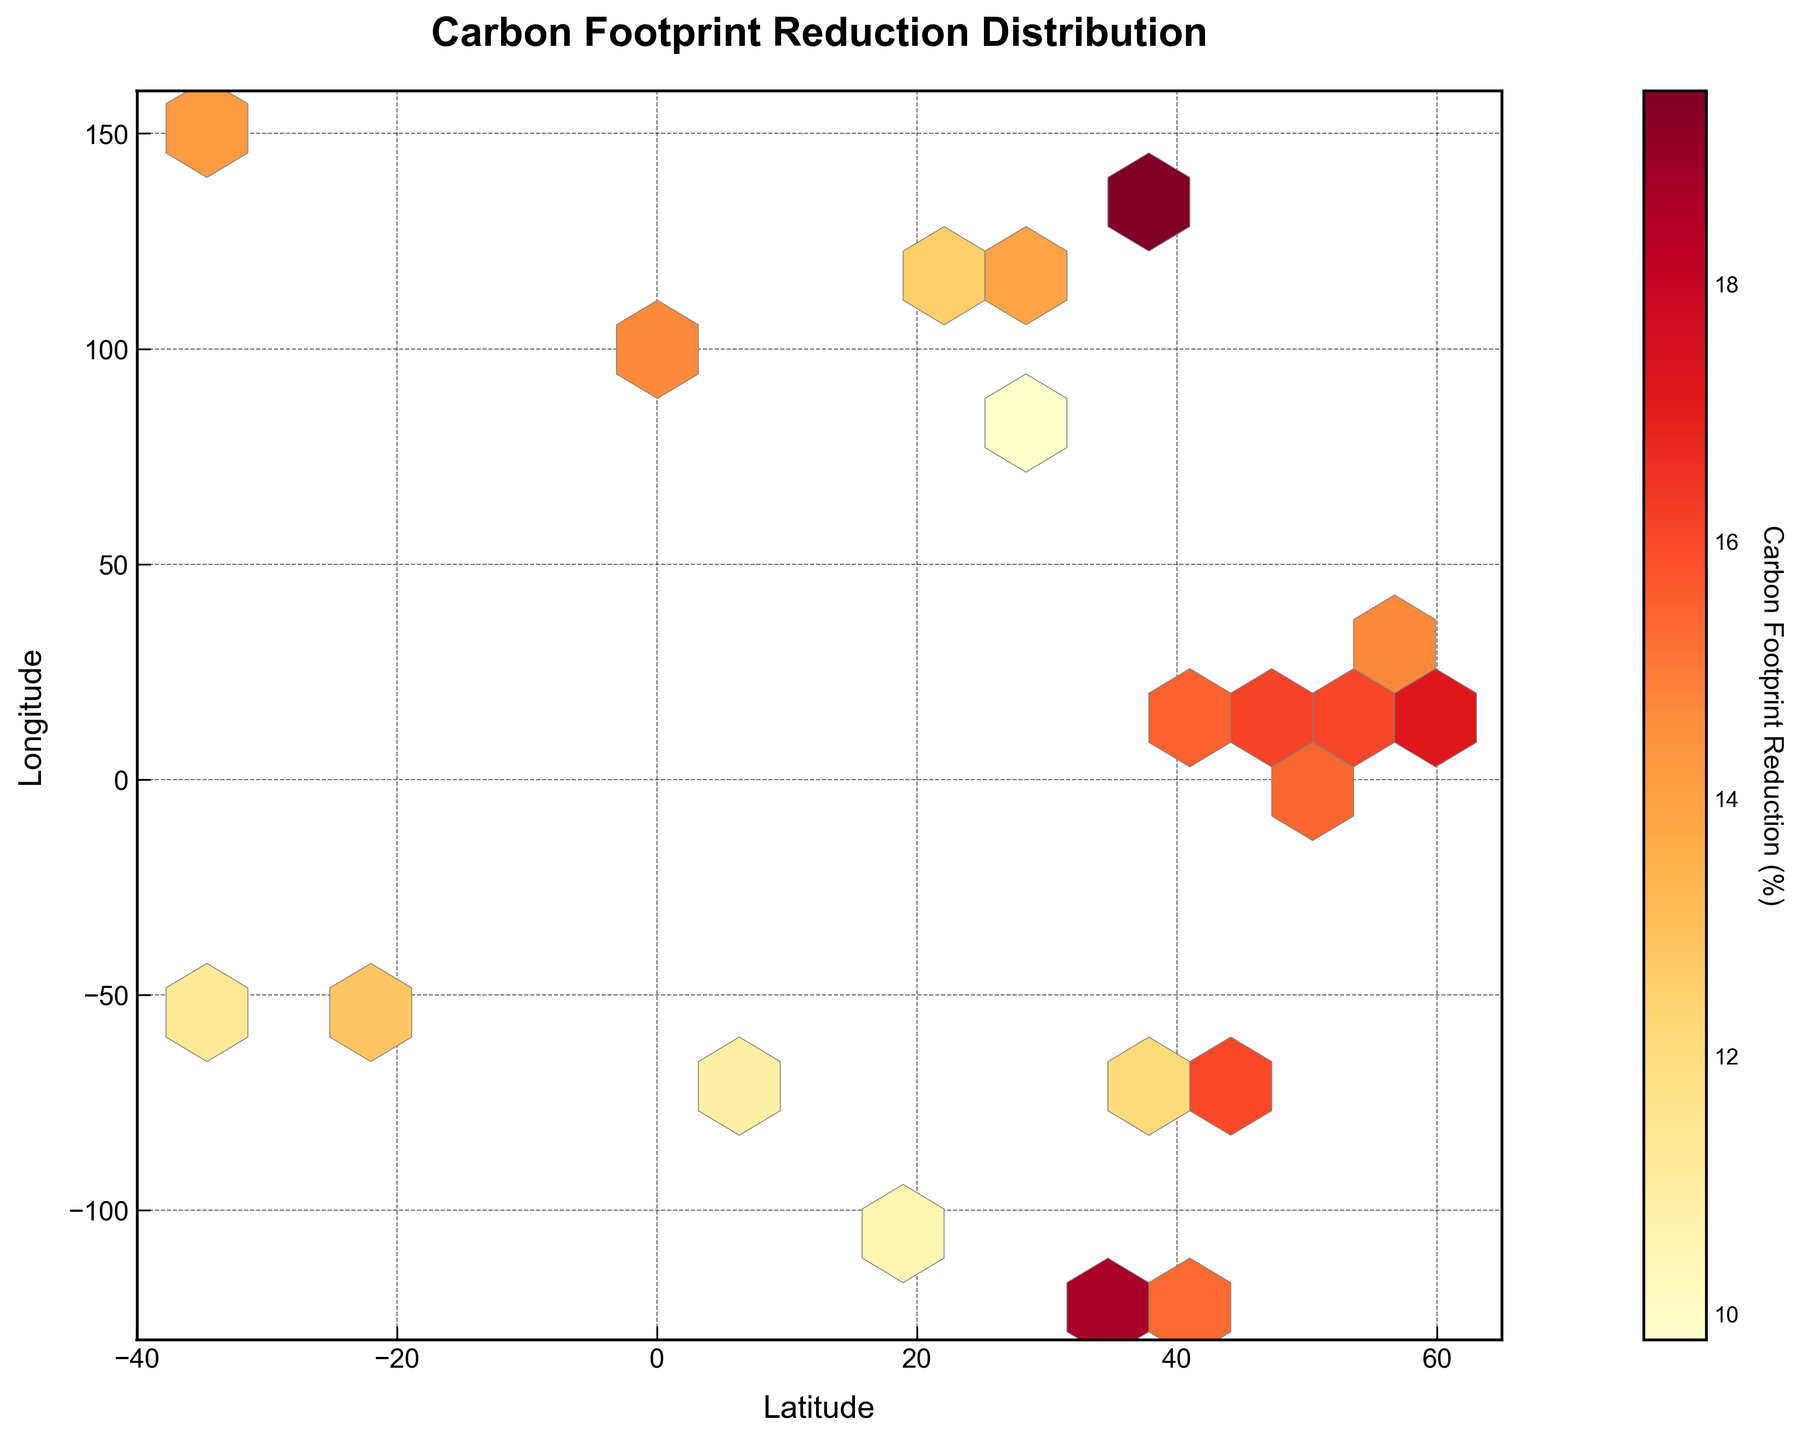What is the title of the hexbin plot? The title can be seen at the top of the plot. It is usually written in larger or bold text to highlight its importance. In this case, the title is "Carbon Footprint Reduction Distribution".
Answer: Carbon Footprint Reduction Distribution What do the x-axis and y-axis represent in this plot? The labels for the x-axis and y-axis can be found next to the respective axes. The x-axis is labeled "Latitude" and the y-axis is labeled "Longitude".
Answer: Latitude and Longitude What is the color indicating in this plot? The color represents the value of the carbon footprint reduction. This can be inferred from the color bar on the right side of the plot, which is labeled "Carbon Footprint Reduction (%)".
Answer: Carbon Footprint Reduction (%) Which area has the highest density of data points and what could this imply? The highest density of data points is indicated by the brightest colors in the hexbin plot. In this case, areas around 50°N (latitude) and near 10°E to 20°E (longitude) show higher density, implying significant data point clustering in this region.
Answer: Around 50°N and 10-20°E How many hexagons are used to bin the data in this plot? The number of hexagons can be noted by looking at the grid structure on the plot. It is mentioned in the code as “gridsize=15”, which indicates a 15x15 hexagonal grid pattern.
Answer: 15x15 In which regions are the lowest carbon footprint reductions observed? The lowest carbon footprint reductions can be identified by the darkest colors in the hexbin plot. Areas around 40°N, -100°E, and around the equator (such as 0° latitude) show lower reductions.
Answer: Around 40°N, -100°E, and equator Compare the carbon footprint reductions in Europe and Asia. By observing the color intensity over different regions, Europe (specific latitudes and longitudes such as 40°N-60°N, 0°E-30°E) generally has higher reductions (brighter hue) than parts of Asia (for instance, around 20°N, 120°E).
Answer: Europe has higher reductions than Asia What is the range of latitudes and longitudes covered in this plot? The range is determined by observing the axis limits specified. The x-axis (latitude) ranges from -40 to 65, and the y-axis (longitude) ranges from -130 to 160.
Answer: Latitude: -40 to 65, Longitude: -130 to 160 Where in the world does the hexbin plot show the most significant carbon footprint reduction? Significant carbon footprint reduction is indicated by the areas with the most intense colors (reds/oranges). These are found in high-density regions which include specific coordinates like 35.7N, 139.8E (Tokyo), and 40.7N, -74.0E (New York).
Answer: Tokyo and New York How effective are sustainable manufacturing processes in the Southern Hemisphere according to the plot? By examining the color shades in the southern hemisphere (below the equator, 0° latitude), it can be seen that the effectiveness varies. Darker colors like around -33.9, 151.2 suggest less reduction compared to the brighter regions in the Northern Hemisphere.
Answer: Less effective in the Southern Hemisphere 